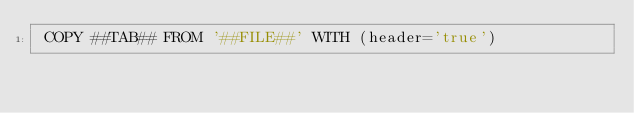Convert code to text. <code><loc_0><loc_0><loc_500><loc_500><_SQL_> COPY ##TAB## FROM '##FILE##' WITH (header='true')
</code> 